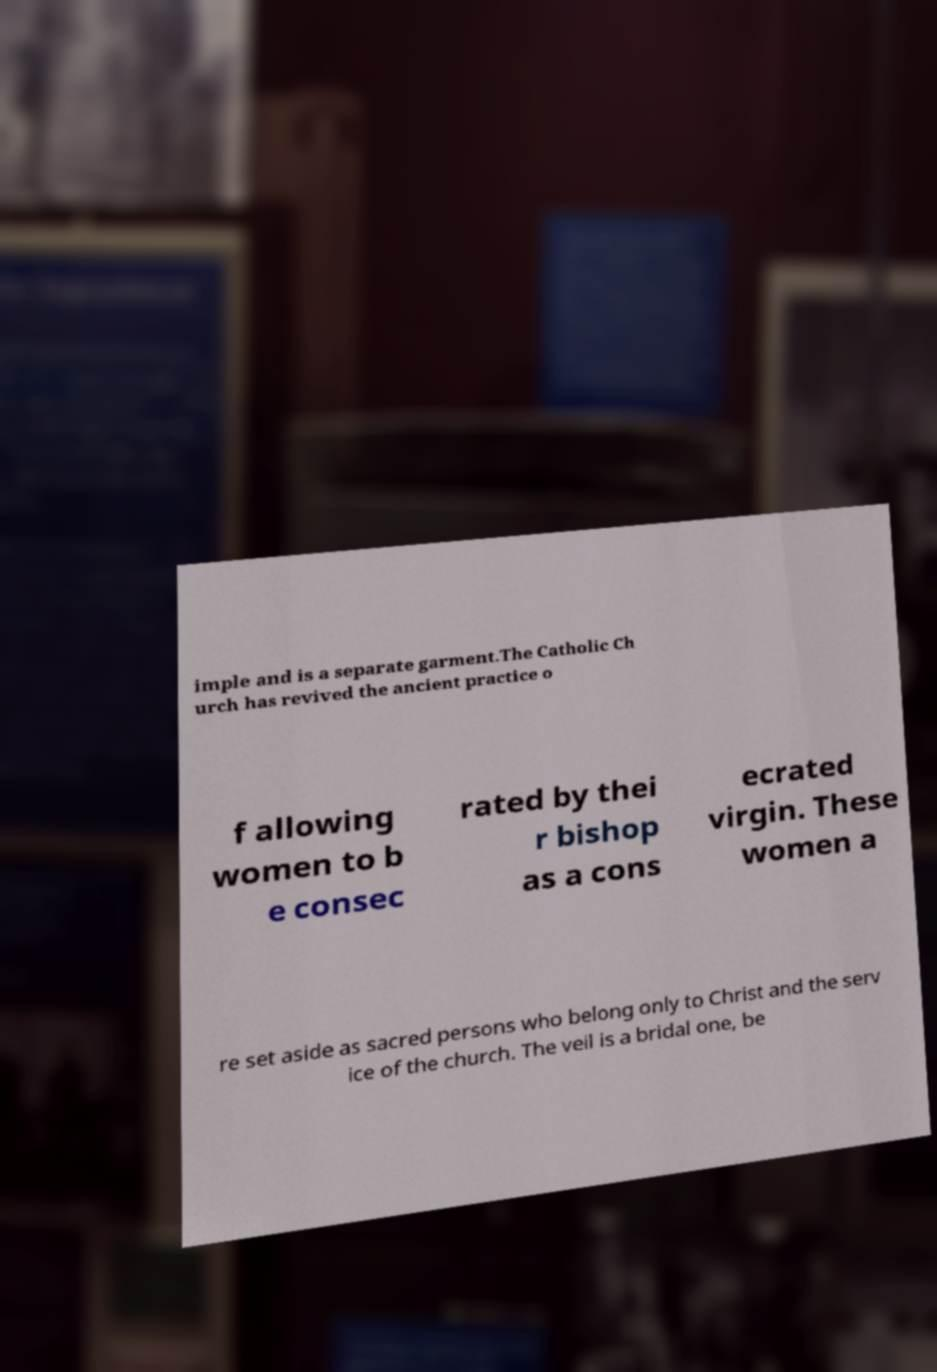What messages or text are displayed in this image? I need them in a readable, typed format. imple and is a separate garment.The Catholic Ch urch has revived the ancient practice o f allowing women to b e consec rated by thei r bishop as a cons ecrated virgin. These women a re set aside as sacred persons who belong only to Christ and the serv ice of the church. The veil is a bridal one, be 